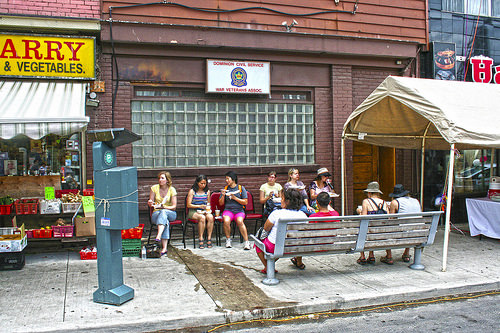<image>
Can you confirm if the phone is next to the lady? No. The phone is not positioned next to the lady. They are located in different areas of the scene. 